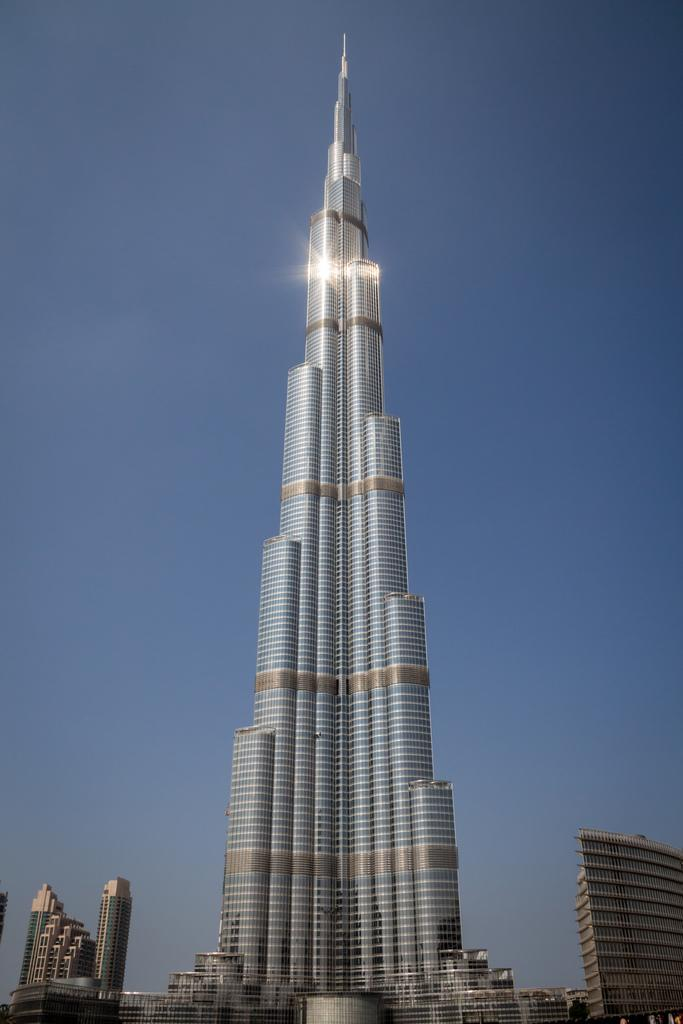What structures are located at the bottom of the image? There are buildings at the bottom of the image. What can be seen in the background of the image? The sky is visible in the background of the image. Where is the giraffe located in the image? There is no giraffe present in the image. What type of liquid can be seen flowing from the buildings in the image? There is no liquid flowing from the buildings in the image. 